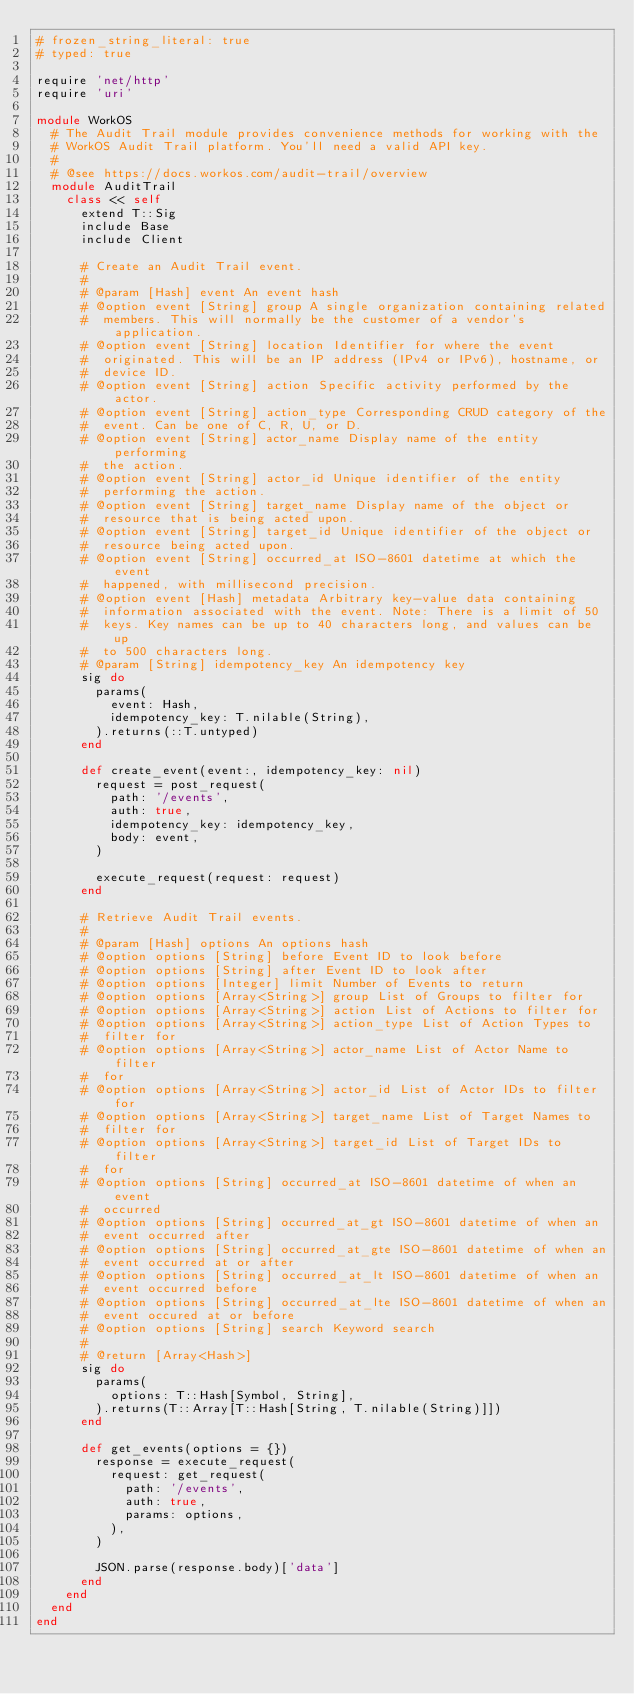<code> <loc_0><loc_0><loc_500><loc_500><_Ruby_># frozen_string_literal: true
# typed: true

require 'net/http'
require 'uri'

module WorkOS
  # The Audit Trail module provides convenience methods for working with the
  # WorkOS Audit Trail platform. You'll need a valid API key.
  #
  # @see https://docs.workos.com/audit-trail/overview
  module AuditTrail
    class << self
      extend T::Sig
      include Base
      include Client

      # Create an Audit Trail event.
      #
      # @param [Hash] event An event hash
      # @option event [String] group A single organization containing related
      #  members. This will normally be the customer of a vendor's application.
      # @option event [String] location Identifier for where the event
      #  originated. This will be an IP address (IPv4 or IPv6), hostname, or
      #  device ID.
      # @option event [String] action Specific activity performed by the actor.
      # @option event [String] action_type Corresponding CRUD category of the
      #  event. Can be one of C, R, U, or D.
      # @option event [String] actor_name Display name of the entity performing
      #  the action.
      # @option event [String] actor_id Unique identifier of the entity
      #  performing the action.
      # @option event [String] target_name Display name of the object or
      #  resource that is being acted upon.
      # @option event [String] target_id Unique identifier of the object or
      #  resource being acted upon.
      # @option event [String] occurred_at ISO-8601 datetime at which the event
      #  happened, with millisecond precision.
      # @option event [Hash] metadata Arbitrary key-value data containing
      #  information associated with the event. Note: There is a limit of 50
      #  keys. Key names can be up to 40 characters long, and values can be up
      #  to 500 characters long.
      # @param [String] idempotency_key An idempotency key
      sig do
        params(
          event: Hash,
          idempotency_key: T.nilable(String),
        ).returns(::T.untyped)
      end

      def create_event(event:, idempotency_key: nil)
        request = post_request(
          path: '/events',
          auth: true,
          idempotency_key: idempotency_key,
          body: event,
        )

        execute_request(request: request)
      end

      # Retrieve Audit Trail events.
      #
      # @param [Hash] options An options hash
      # @option options [String] before Event ID to look before
      # @option options [String] after Event ID to look after
      # @option options [Integer] limit Number of Events to return
      # @option options [Array<String>] group List of Groups to filter for
      # @option options [Array<String>] action List of Actions to filter for
      # @option options [Array<String>] action_type List of Action Types to
      #  filter for
      # @option options [Array<String>] actor_name List of Actor Name to filter
      #  for
      # @option options [Array<String>] actor_id List of Actor IDs to filter for
      # @option options [Array<String>] target_name List of Target Names to
      #  filter for
      # @option options [Array<String>] target_id List of Target IDs to filter
      #  for
      # @option options [String] occurred_at ISO-8601 datetime of when an event
      #  occurred
      # @option options [String] occurred_at_gt ISO-8601 datetime of when an
      #  event occurred after
      # @option options [String] occurred_at_gte ISO-8601 datetime of when an
      #  event occurred at or after
      # @option options [String] occurred_at_lt ISO-8601 datetime of when an
      #  event occurred before
      # @option options [String] occurred_at_lte ISO-8601 datetime of when an
      #  event occured at or before
      # @option options [String] search Keyword search
      #
      # @return [Array<Hash>]
      sig do
        params(
          options: T::Hash[Symbol, String],
        ).returns(T::Array[T::Hash[String, T.nilable(String)]])
      end

      def get_events(options = {})
        response = execute_request(
          request: get_request(
            path: '/events',
            auth: true,
            params: options,
          ),
        )

        JSON.parse(response.body)['data']
      end
    end
  end
end
</code> 